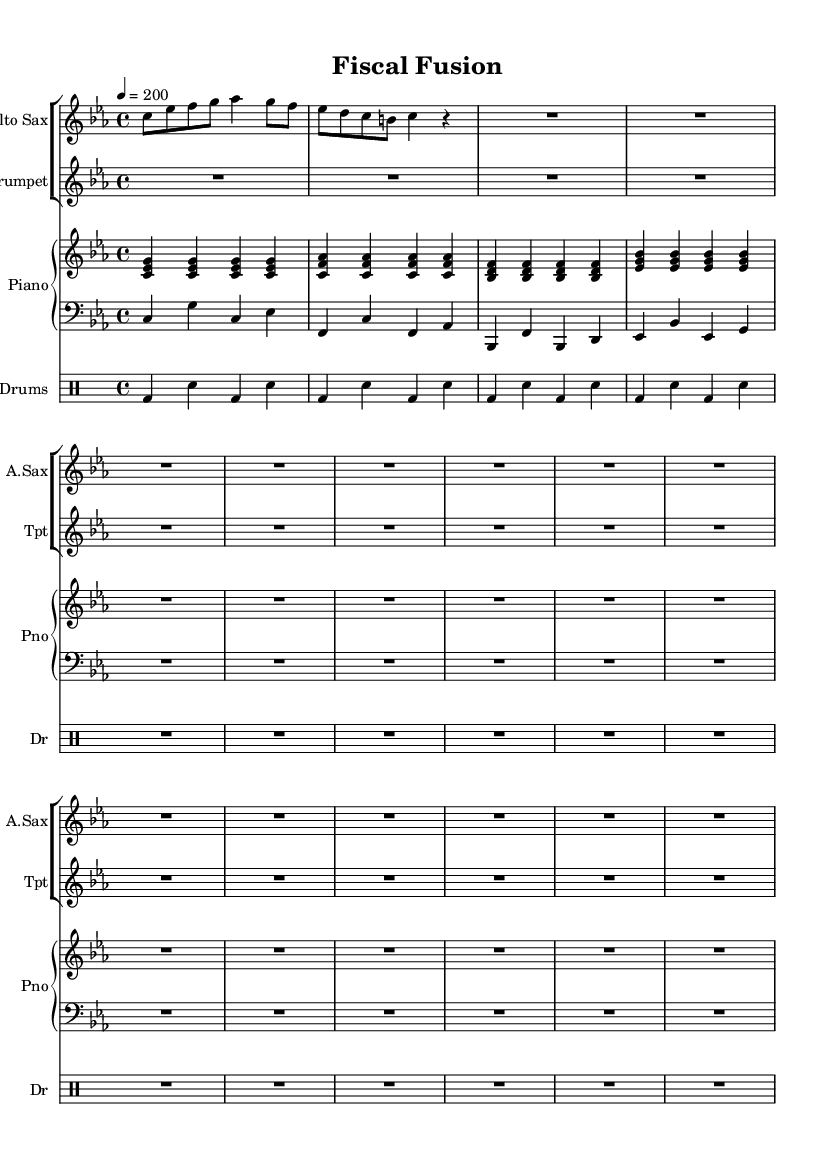What is the key signature of this music? The key signature is indicated by the placement of the flats or sharps at the beginning of the staff. In this case, there are three flats which typically denote a C minor key signature.
Answer: C minor What is the time signature of this music? The time signature is found at the beginning of the staff and indicates how many beats are in a measure. Here, 4/4 means there are four beats in each measure, which is standard for jazz.
Answer: 4/4 What is the tempo marking for this piece? The tempo marking is usually indicated in beats per minute. In this sheet music, it is marked as a quarter note equals 200 beats per minute, indicating a fast tempo suitable for bebop jazz.
Answer: 200 How many bars are indicated for the alto saxophone line? To find the number of bars, count the individual measure lines in the alto sax part. There are three measures clearly shown in this staff.
Answer: 3 What type of ensemble is this music written for? The ensemble type can be determined by the instruments listed in the score. This piece includes an alto saxophone, trumpet, piano, bass, and drums, which is characteristic of a jazz combo.
Answer: Jazz combo What rhythmic pattern is primarily used in the drum part? By analyzing the drum notation, one can see it consists of alternating bass drum (bd) and snare (sn) hits in a steady pattern throughout the portion provided, common in a swing feel.
Answer: Alternating bass and snare What adds complexity to the bebop style in this piece? The complexity derives from the arrangements of the chords in the piano part, which use extended harmonies and syncopated rhythms, both hallmark features of bebop jazz.
Answer: Extended harmonies and syncopation 